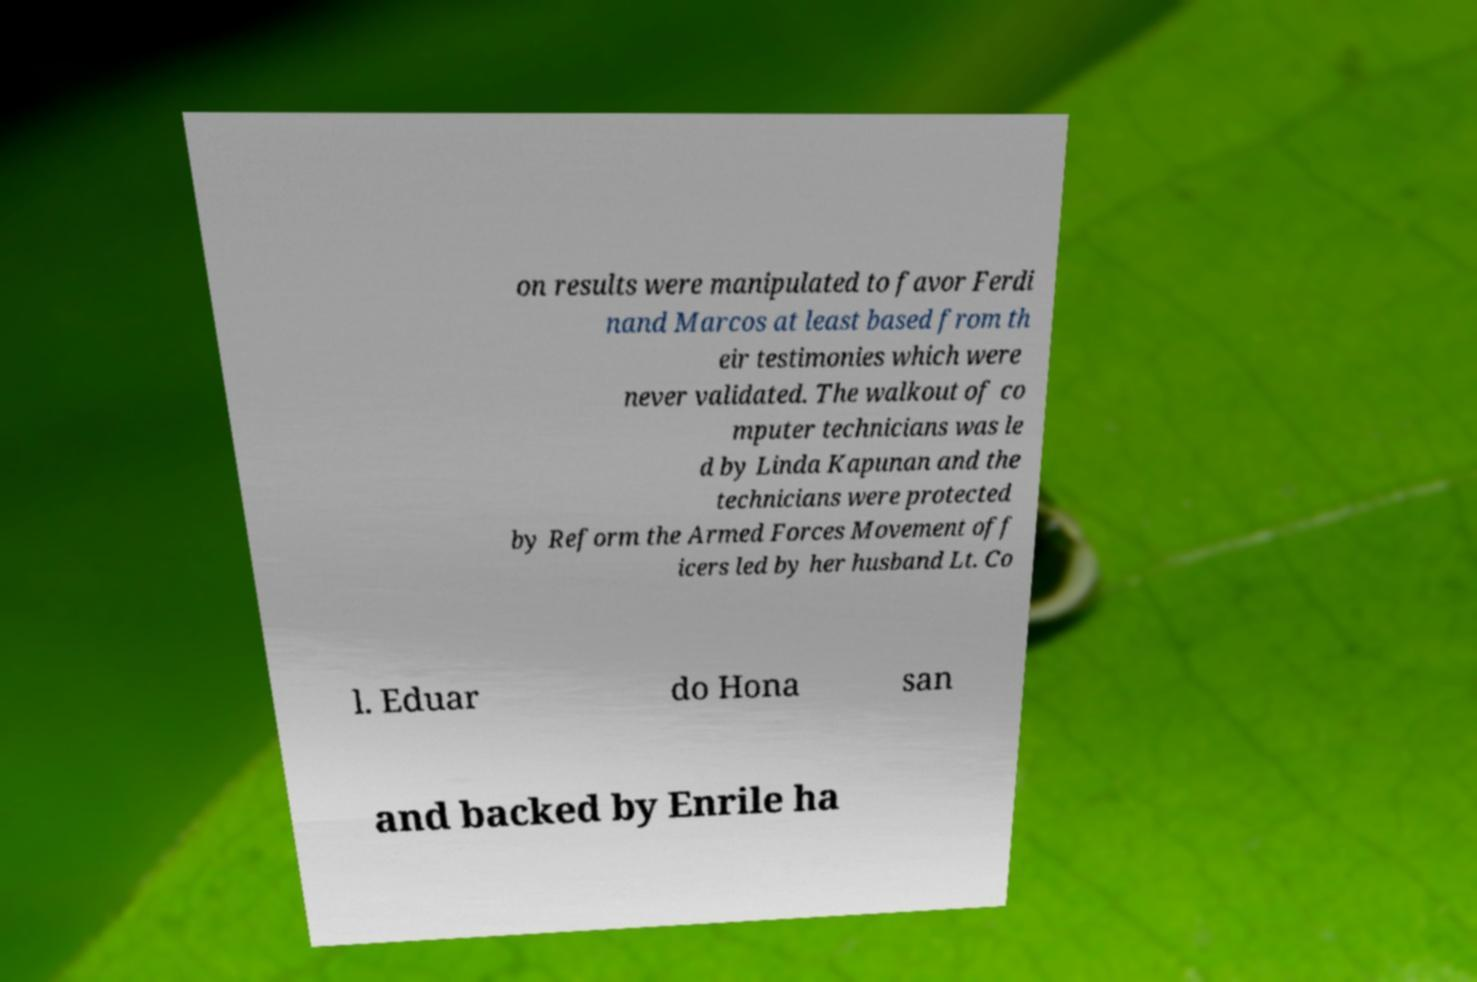For documentation purposes, I need the text within this image transcribed. Could you provide that? on results were manipulated to favor Ferdi nand Marcos at least based from th eir testimonies which were never validated. The walkout of co mputer technicians was le d by Linda Kapunan and the technicians were protected by Reform the Armed Forces Movement off icers led by her husband Lt. Co l. Eduar do Hona san and backed by Enrile ha 